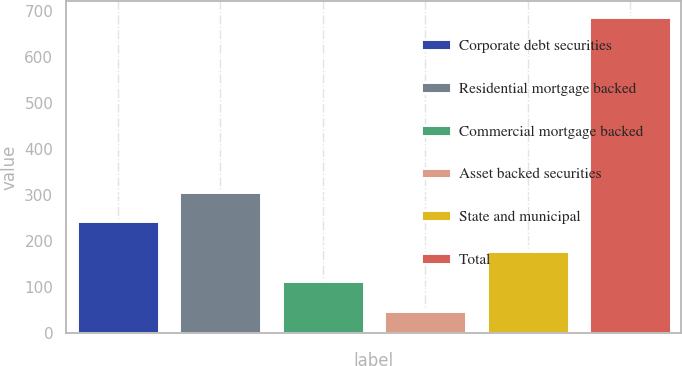Convert chart to OTSL. <chart><loc_0><loc_0><loc_500><loc_500><bar_chart><fcel>Corporate debt securities<fcel>Residential mortgage backed<fcel>Commercial mortgage backed<fcel>Asset backed securities<fcel>State and municipal<fcel>Total<nl><fcel>243.9<fcel>307.8<fcel>112.9<fcel>49<fcel>180<fcel>688<nl></chart> 